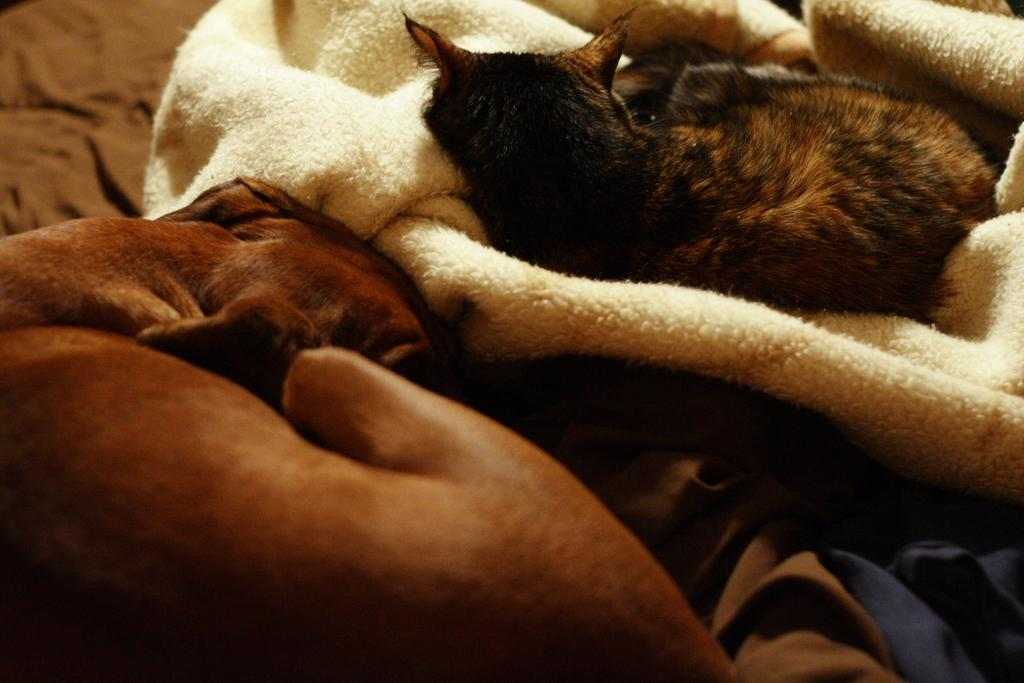What types of living organisms can be seen in the image? There are animals in the image. What are the animals doing in the image? The animals are lying on clothes. What type of mass can be seen on the mountain in the image? There is no mountain or mass present in the image; it features animals lying on clothes. How many bags of popcorn are visible in the image? There are no bags of popcorn present in the image. 